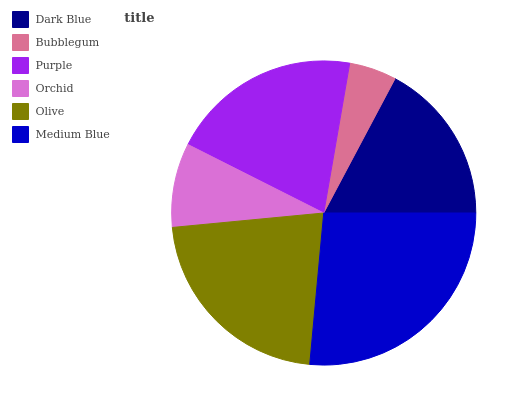Is Bubblegum the minimum?
Answer yes or no. Yes. Is Medium Blue the maximum?
Answer yes or no. Yes. Is Purple the minimum?
Answer yes or no. No. Is Purple the maximum?
Answer yes or no. No. Is Purple greater than Bubblegum?
Answer yes or no. Yes. Is Bubblegum less than Purple?
Answer yes or no. Yes. Is Bubblegum greater than Purple?
Answer yes or no. No. Is Purple less than Bubblegum?
Answer yes or no. No. Is Purple the high median?
Answer yes or no. Yes. Is Dark Blue the low median?
Answer yes or no. Yes. Is Dark Blue the high median?
Answer yes or no. No. Is Olive the low median?
Answer yes or no. No. 